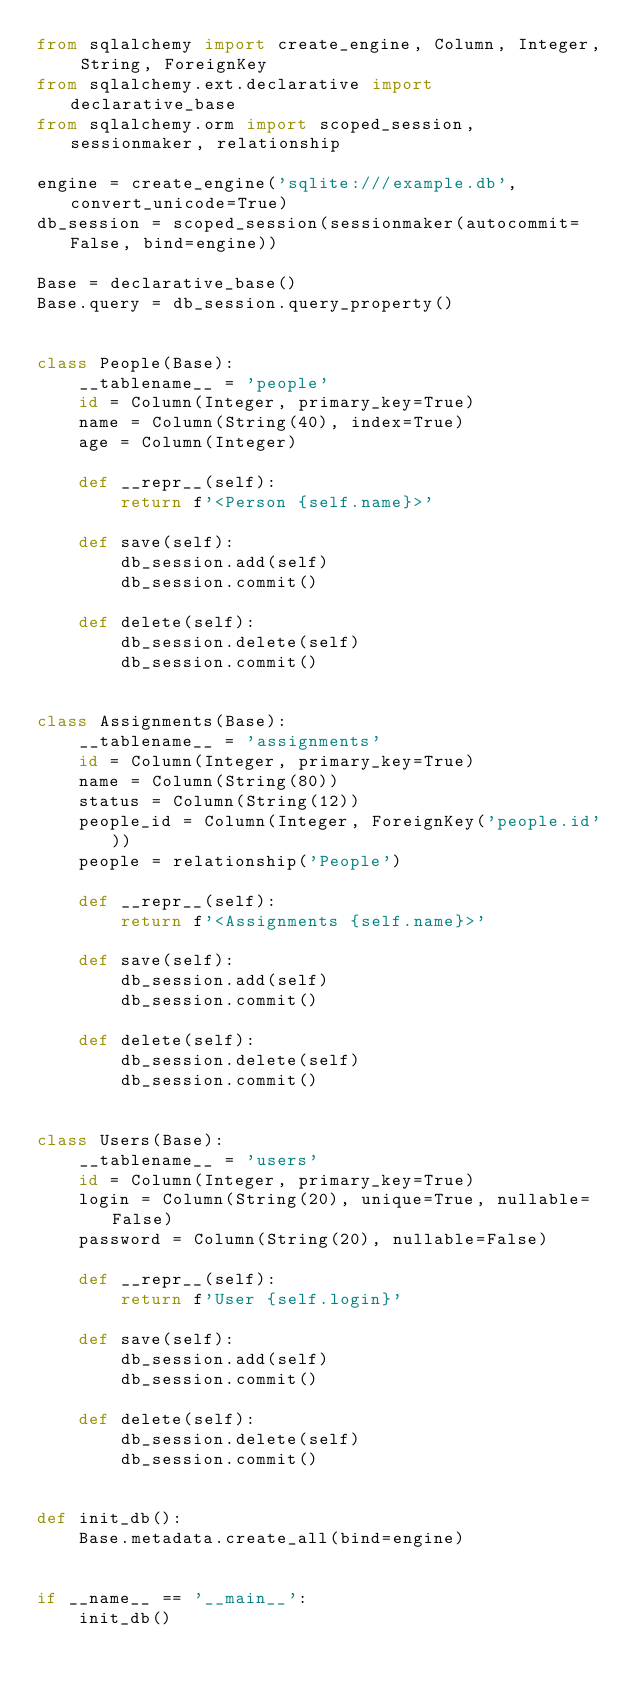Convert code to text. <code><loc_0><loc_0><loc_500><loc_500><_Python_>from sqlalchemy import create_engine, Column, Integer, String, ForeignKey
from sqlalchemy.ext.declarative import declarative_base
from sqlalchemy.orm import scoped_session, sessionmaker, relationship

engine = create_engine('sqlite:///example.db', convert_unicode=True)
db_session = scoped_session(sessionmaker(autocommit=False, bind=engine))

Base = declarative_base()
Base.query = db_session.query_property()


class People(Base):
    __tablename__ = 'people'
    id = Column(Integer, primary_key=True)
    name = Column(String(40), index=True)
    age = Column(Integer)

    def __repr__(self):
        return f'<Person {self.name}>'

    def save(self):
        db_session.add(self)
        db_session.commit()

    def delete(self):
        db_session.delete(self)
        db_session.commit()


class Assignments(Base):
    __tablename__ = 'assignments'
    id = Column(Integer, primary_key=True)
    name = Column(String(80))
    status = Column(String(12))
    people_id = Column(Integer, ForeignKey('people.id'))
    people = relationship('People')

    def __repr__(self):
        return f'<Assignments {self.name}>'

    def save(self):
        db_session.add(self)
        db_session.commit()

    def delete(self):
        db_session.delete(self)
        db_session.commit()


class Users(Base):
    __tablename__ = 'users'
    id = Column(Integer, primary_key=True)
    login = Column(String(20), unique=True, nullable=False)
    password = Column(String(20), nullable=False)

    def __repr__(self):
        return f'User {self.login}'

    def save(self):
        db_session.add(self)
        db_session.commit()

    def delete(self):
        db_session.delete(self)
        db_session.commit()


def init_db():
    Base.metadata.create_all(bind=engine)


if __name__ == '__main__':
    init_db()
</code> 